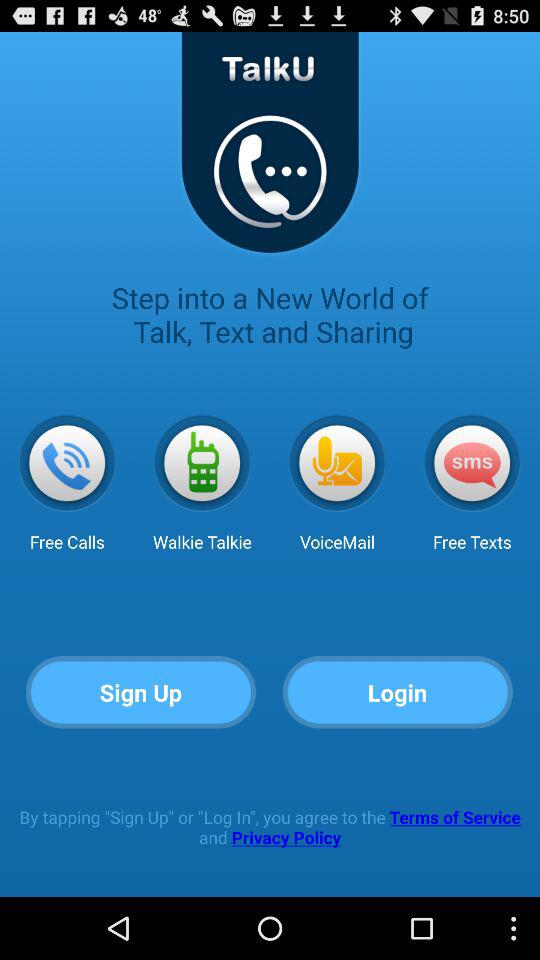What is the name of application? The name of application is "TalkU". 